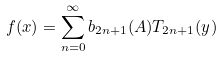Convert formula to latex. <formula><loc_0><loc_0><loc_500><loc_500>f ( x ) = \sum _ { n = 0 } ^ { \infty } b _ { 2 n + 1 } ( A ) T _ { 2 n + 1 } ( y )</formula> 